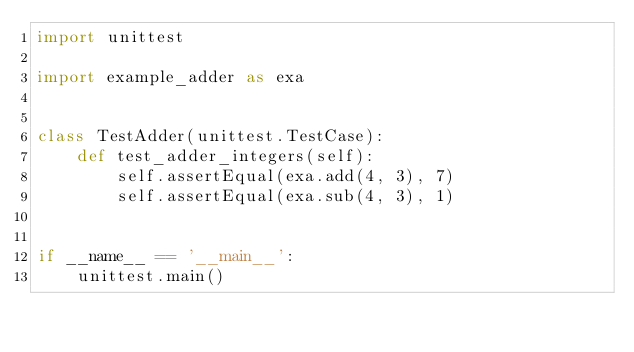Convert code to text. <code><loc_0><loc_0><loc_500><loc_500><_Python_>import unittest

import example_adder as exa


class TestAdder(unittest.TestCase):
    def test_adder_integers(self):
        self.assertEqual(exa.add(4, 3), 7)
        self.assertEqual(exa.sub(4, 3), 1)


if __name__ == '__main__':
    unittest.main()
</code> 